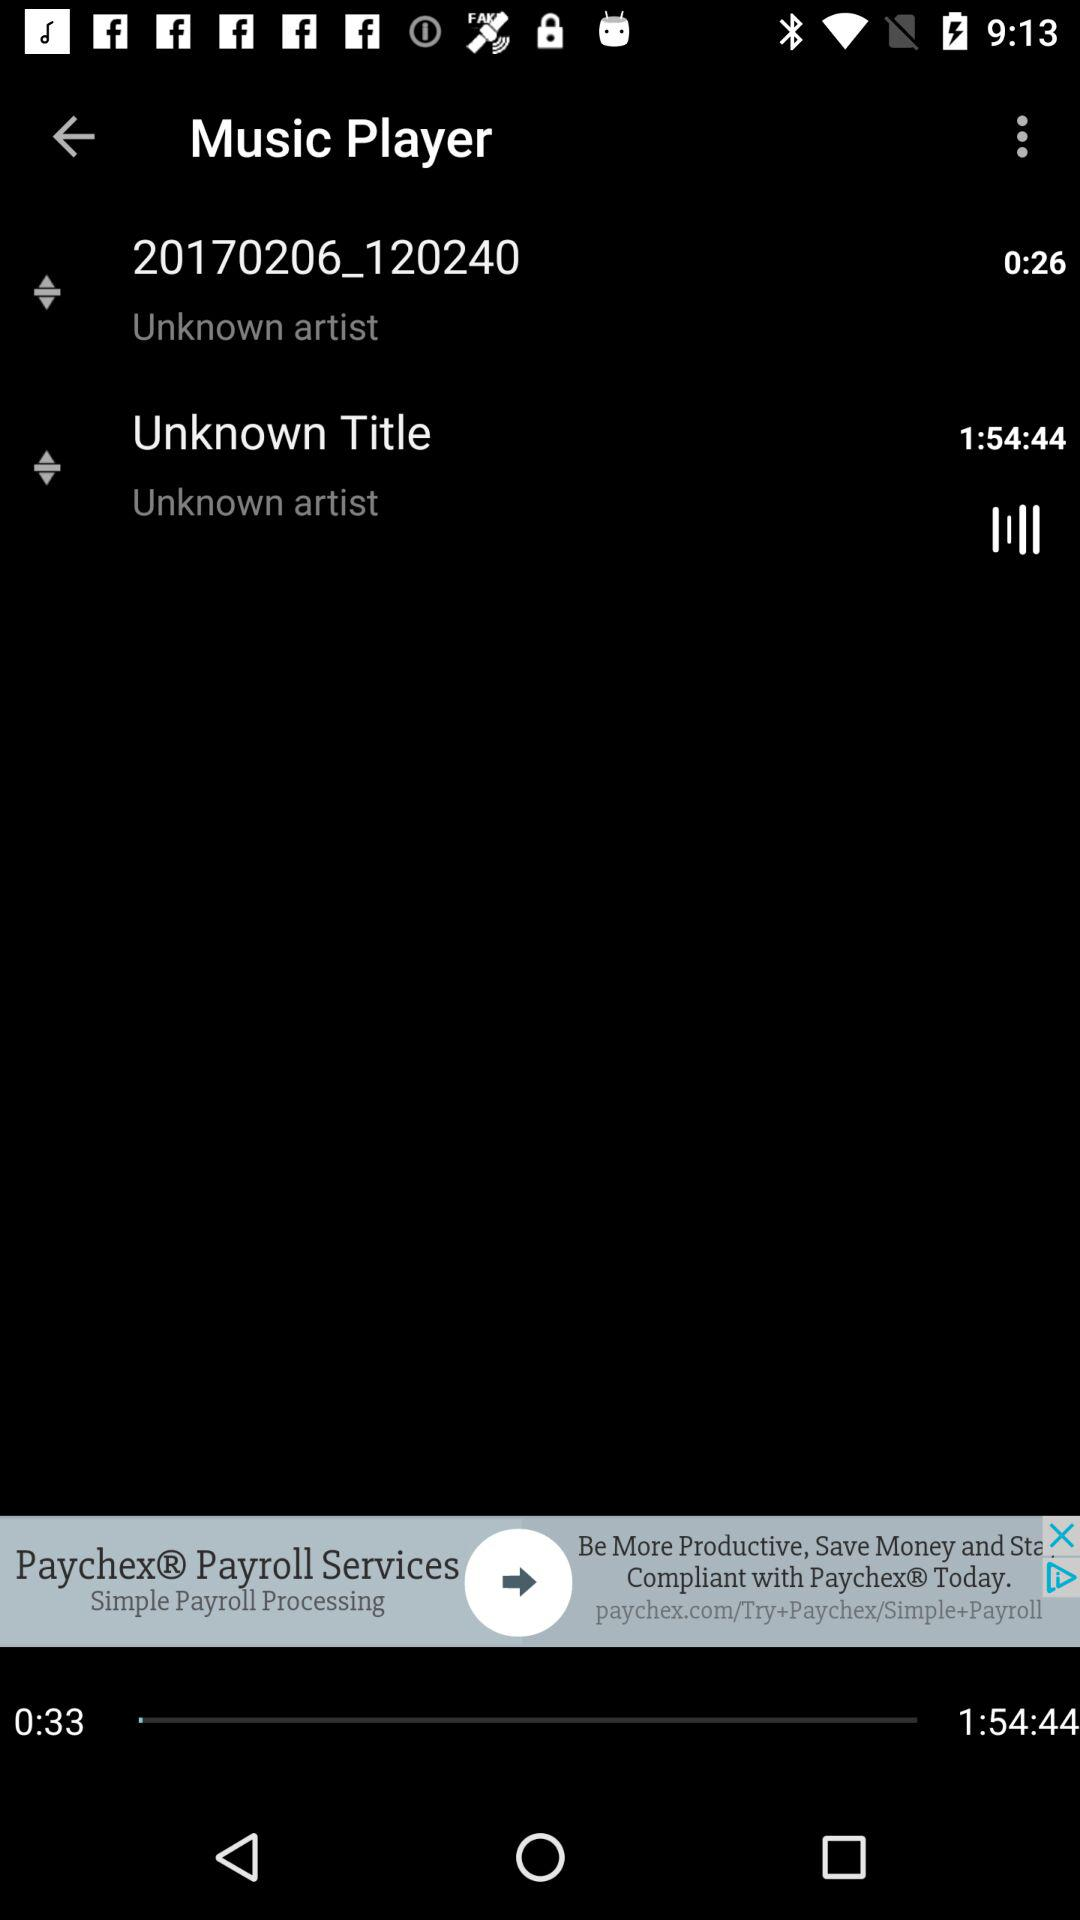What is the duration of "20170206_120240"? The duration is 26 seconds. 